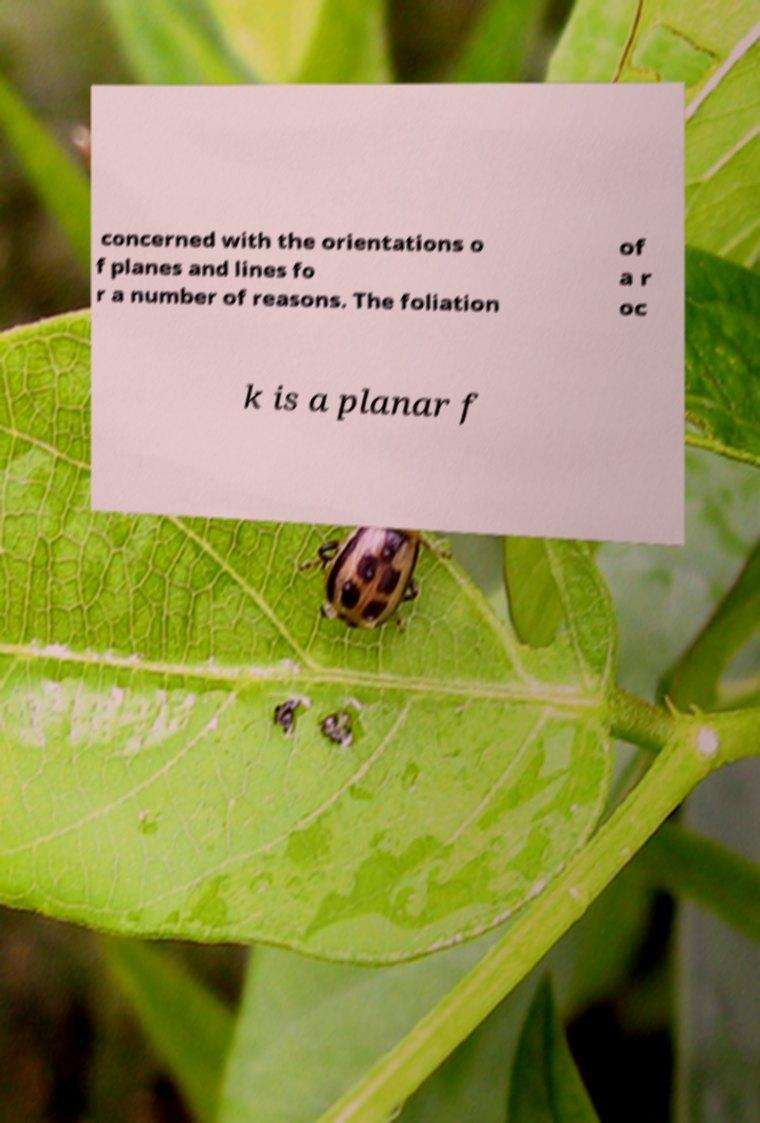Can you accurately transcribe the text from the provided image for me? concerned with the orientations o f planes and lines fo r a number of reasons. The foliation of a r oc k is a planar f 